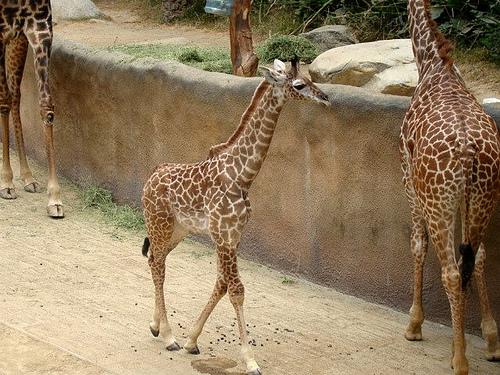Are there any drippings on the ground?
Answer briefly. Yes. How many animals are standing near the rock wall?
Concise answer only. 3. How many adults animals do you see?
Be succinct. 2. 